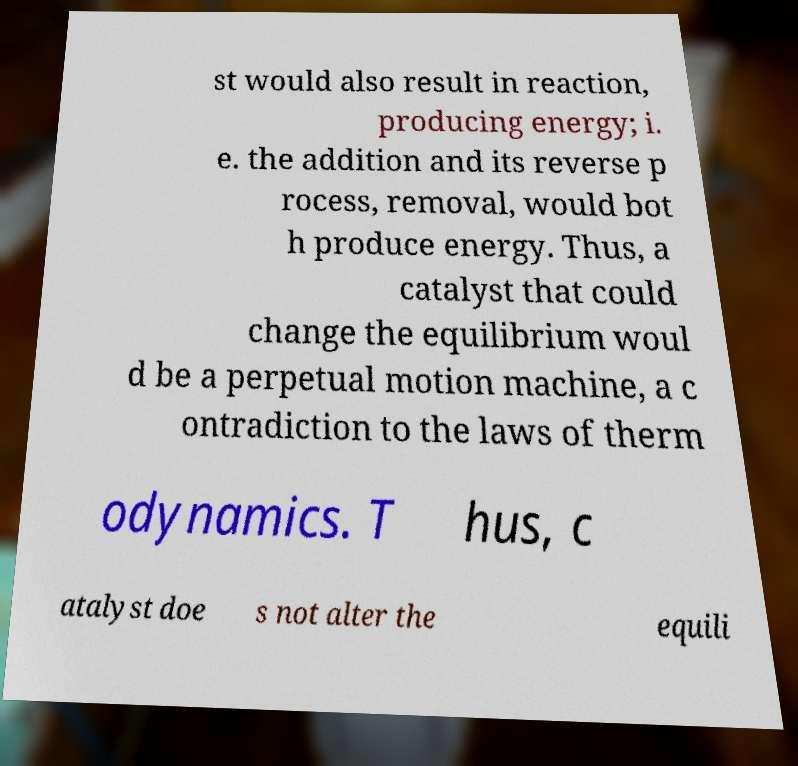Could you assist in decoding the text presented in this image and type it out clearly? st would also result in reaction, producing energy; i. e. the addition and its reverse p rocess, removal, would bot h produce energy. Thus, a catalyst that could change the equilibrium woul d be a perpetual motion machine, a c ontradiction to the laws of therm odynamics. T hus, c atalyst doe s not alter the equili 